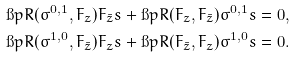<formula> <loc_0><loc_0><loc_500><loc_500>\i p { R ( \sigma ^ { 0 , 1 } , F _ { z } ) F _ { \bar { z } } } { s } + \i p { R ( F _ { z } , F _ { \bar { z } } ) \sigma ^ { 0 , 1 } } { s } & = 0 , \\ \i p { R ( \sigma ^ { 1 , 0 } , F _ { \bar { z } } ) F _ { z } } { s } + \i p { R ( F _ { \bar { z } } , F _ { z } ) \sigma ^ { 1 , 0 } } { s } & = 0 .</formula> 